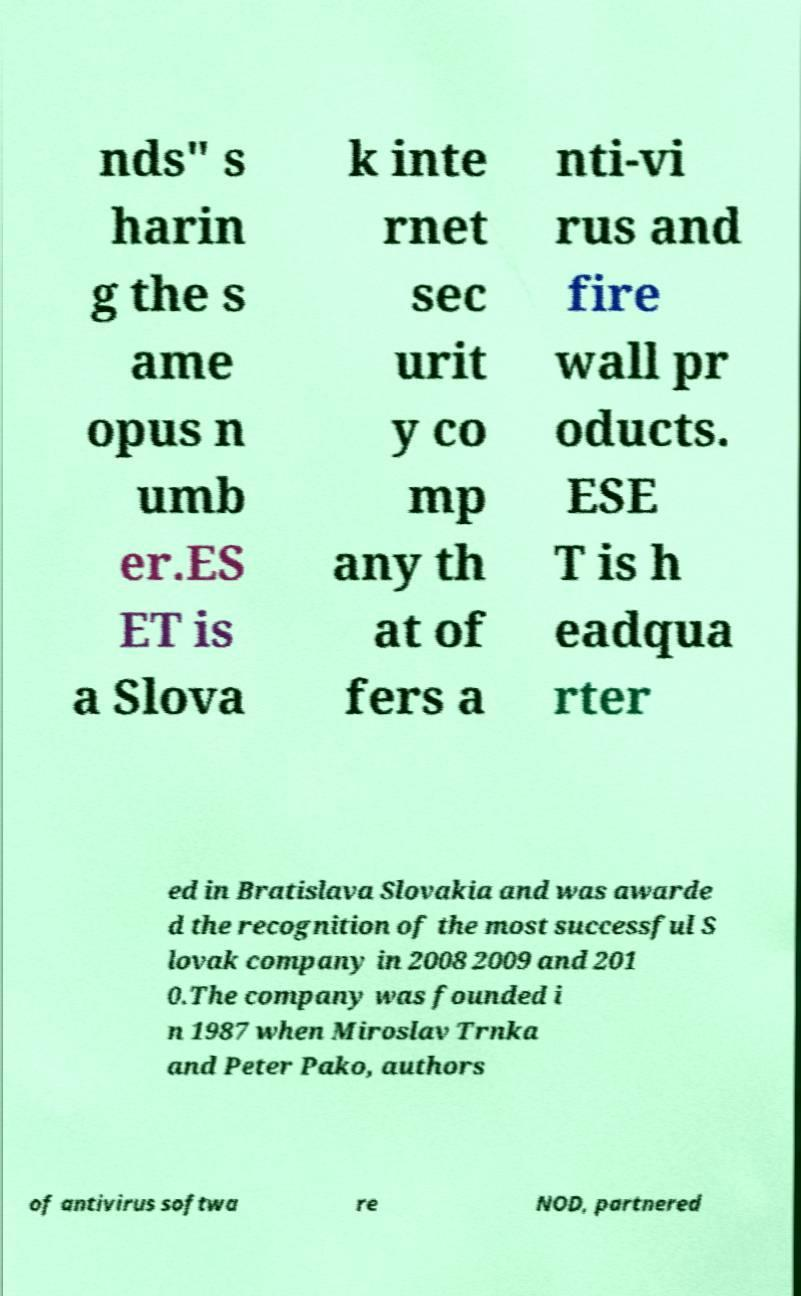Can you read and provide the text displayed in the image?This photo seems to have some interesting text. Can you extract and type it out for me? nds" s harin g the s ame opus n umb er.ES ET is a Slova k inte rnet sec urit y co mp any th at of fers a nti-vi rus and fire wall pr oducts. ESE T is h eadqua rter ed in Bratislava Slovakia and was awarde d the recognition of the most successful S lovak company in 2008 2009 and 201 0.The company was founded i n 1987 when Miroslav Trnka and Peter Pako, authors of antivirus softwa re NOD, partnered 